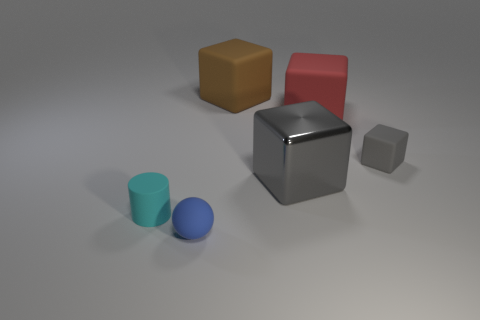The big brown matte thing has what shape?
Provide a short and direct response. Cube. What shape is the small rubber object that is behind the tiny thing that is on the left side of the blue sphere that is on the right side of the cyan matte thing?
Your answer should be compact. Cube. How many other objects are there of the same shape as the big metal thing?
Offer a very short reply. 3. There is a small thing that is right of the large matte thing on the left side of the big shiny cube; what is it made of?
Give a very brief answer. Rubber. Does the tiny blue object have the same material as the tiny object that is right of the matte sphere?
Offer a very short reply. Yes. The object that is both on the left side of the brown rubber thing and to the right of the small cyan cylinder is made of what material?
Offer a terse response. Rubber. The small thing to the right of the large shiny block that is behind the small cyan rubber cylinder is what color?
Offer a very short reply. Gray. There is a big cube in front of the red rubber cube; what is it made of?
Offer a very short reply. Metal. Is the number of brown things less than the number of big red matte cylinders?
Offer a terse response. No. There is a large red rubber object; is it the same shape as the small matte thing that is right of the small ball?
Ensure brevity in your answer.  Yes. 